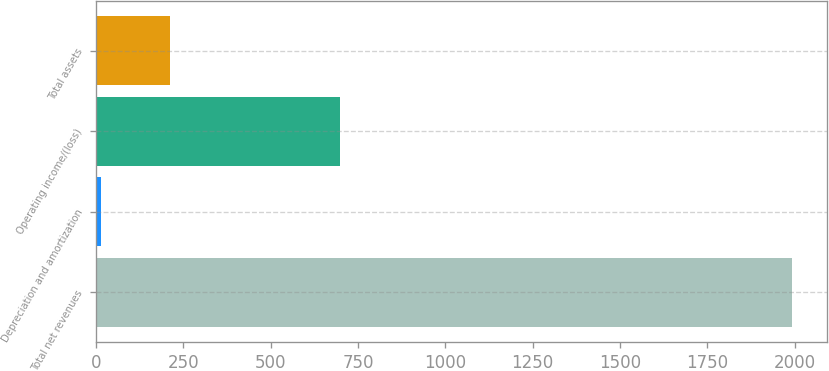Convert chart. <chart><loc_0><loc_0><loc_500><loc_500><bar_chart><fcel>Total net revenues<fcel>Depreciation and amortization<fcel>Operating income/(loss)<fcel>Total assets<nl><fcel>1992.6<fcel>13<fcel>697.5<fcel>210.96<nl></chart> 